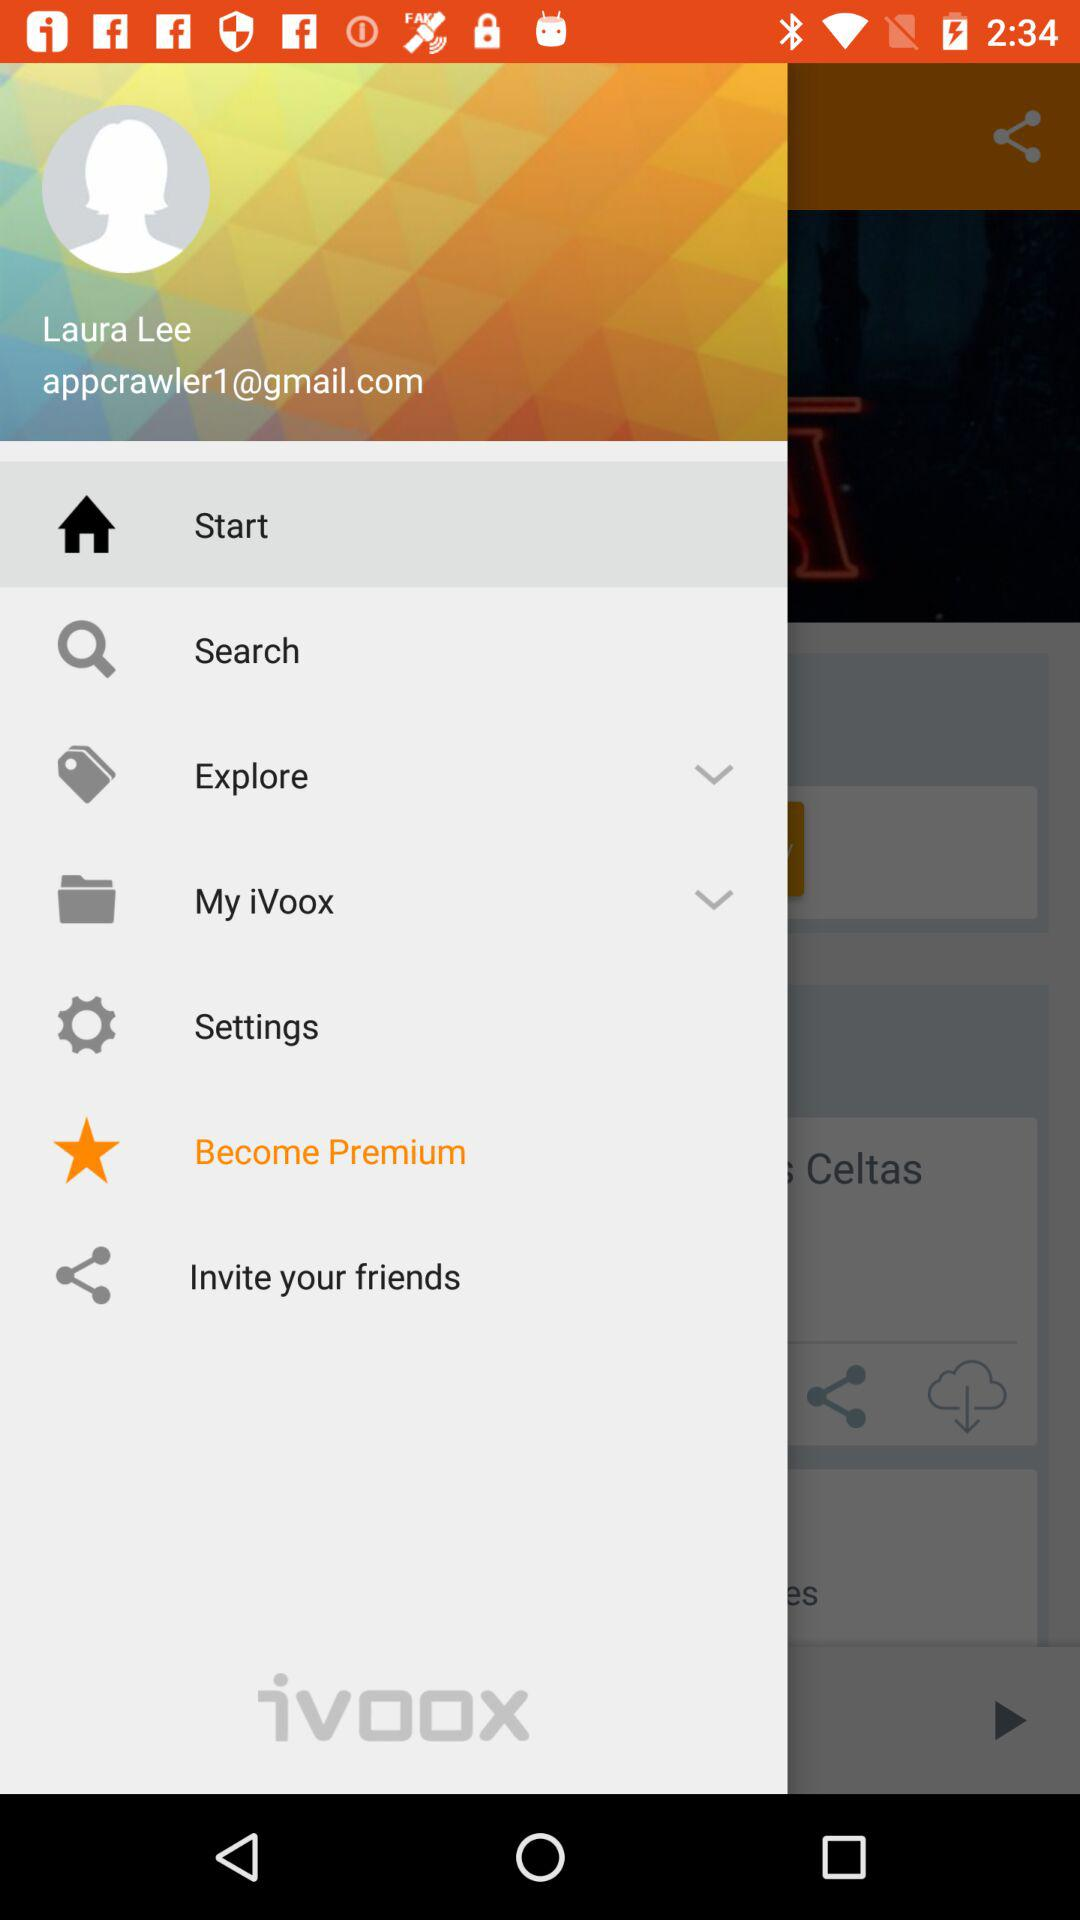What is the name of the user?
Answer the question using a single word or phrase. Laura Lee 